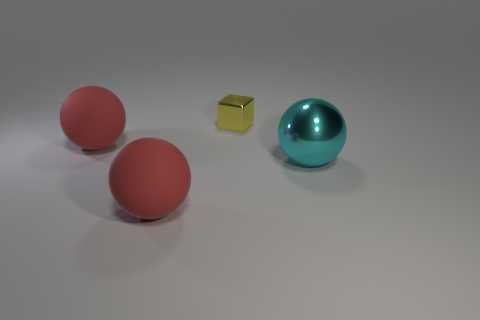Subtract all red balls. How many were subtracted if there are1red balls left? 1 Add 4 rubber things. How many objects exist? 8 Subtract all spheres. How many objects are left? 1 Add 1 tiny shiny objects. How many tiny shiny objects are left? 2 Add 4 big purple rubber cubes. How many big purple rubber cubes exist? 4 Subtract 0 brown cylinders. How many objects are left? 4 Subtract all big cyan spheres. Subtract all balls. How many objects are left? 0 